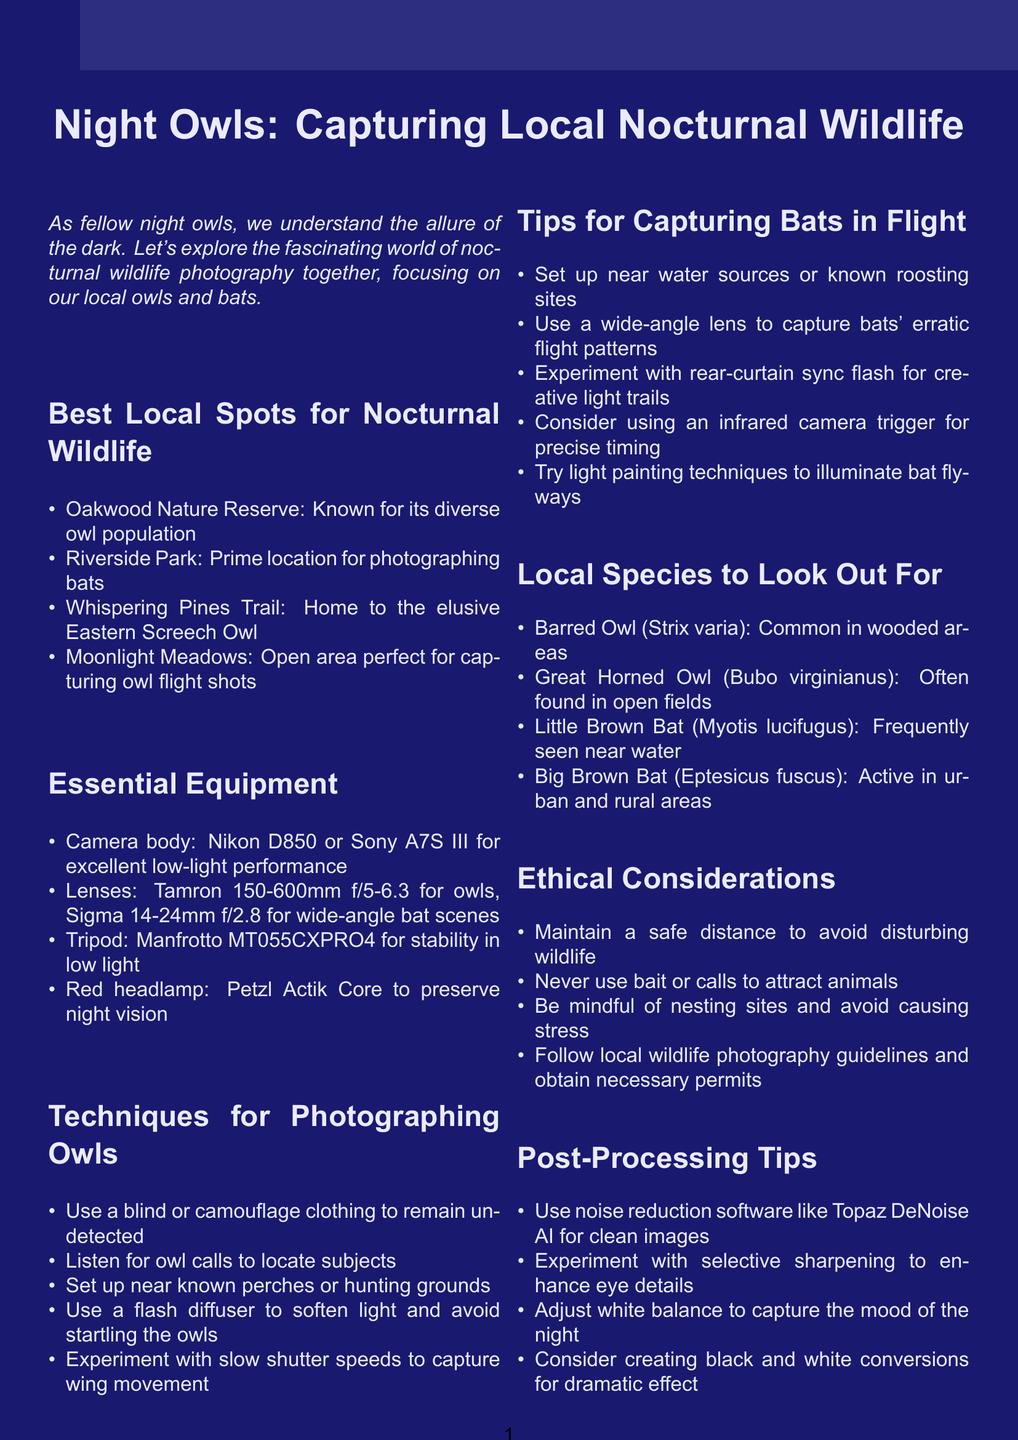What is the title of the brochure? The title of the brochure is presented at the beginning and states the purpose of the document.
Answer: Night Owls: Capturing Local Nocturnal Wildlife Which lens is recommended for photographing owls? The document lists specific equipment and mentions a particular lens for owls.
Answer: Tamron 150-600mm f/5-6.3 What location is described as prime for photographing bats? The brochure includes several locations for wildlife photography, specifying one for bats.
Answer: Riverside Park Name one species of bat mentioned in the document. The document lists various species, including bats, in a dedicated section.
Answer: Little Brown Bat What ethical consideration is suggested for wildlife photography? The document highlights important guidelines to follow when photographing wildlife.
Answer: Maintain a safe distance to avoid disturbing wildlife Why is a red headlamp recommended? The brochure advises on essential equipment and its purpose during nighttime photography.
Answer: To preserve night vision Which technique involves using slow shutter speeds? The document explains techniques specifically for photographing owls, detailing this approach.
Answer: Experiment with slow shutter speeds to capture wing movement How often do community meetups take place? The document talks about community involvement and regular gatherings for photographers.
Answer: Monthly What is a post-processing software mentioned in the brochure? The document includes a section on post-processing tips and mentions specific software.
Answer: Topaz DeNoise AI 